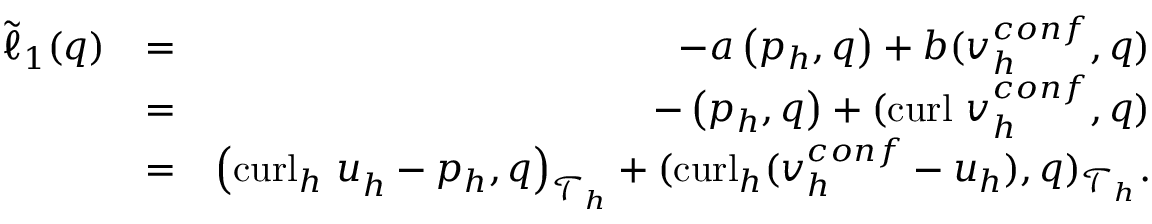Convert formula to latex. <formula><loc_0><loc_0><loc_500><loc_500>\begin{array} { r l r } { \tilde { \ell } _ { 1 } ( q ) } & { = } & { - a \left ( { p } _ { h } , { q } \right ) + b ( v _ { h } ^ { c o n f } , { q } ) } \\ & { = } & { - \left ( p _ { h } , q \right ) + ( c u r l v _ { h } ^ { c o n f } , q ) } \\ & { = } & { \left ( { c u r l _ { h } u } _ { h } - p _ { h } , q \right ) _ { \mathcal { T } _ { h } } + ( c u r l _ { h } ( v _ { h } ^ { c o n f } - u _ { h } ) , q ) _ { \mathcal { T } _ { h } } . } \end{array}</formula> 